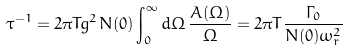<formula> <loc_0><loc_0><loc_500><loc_500>\tau ^ { - 1 } = 2 \pi T g ^ { 2 } N ( 0 ) \int _ { 0 } ^ { \infty } d \Omega \, \frac { A ( \Omega ) } { \Omega } = 2 \pi T \frac { \Gamma _ { 0 } } { N ( 0 ) \omega _ { r } ^ { 2 } }</formula> 